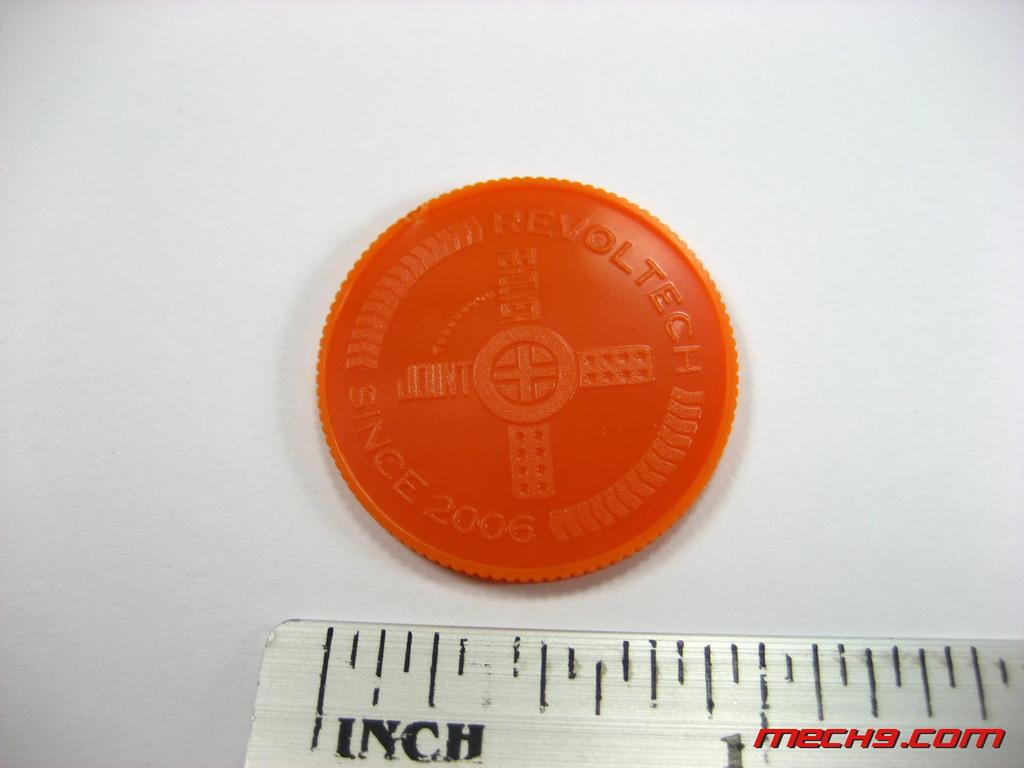Provide a one-sentence caption for the provided image. A orange token reading Revoltech placed above a ruler. 